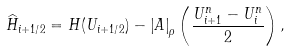<formula> <loc_0><loc_0><loc_500><loc_500>\widehat { H } _ { i + 1 / 2 } = H ( U _ { i + 1 / 2 } ) - \left | A \right | _ { \rho } \left ( \frac { U _ { i + 1 } ^ { n } - U _ { i } ^ { n } } { 2 } \right ) ,</formula> 